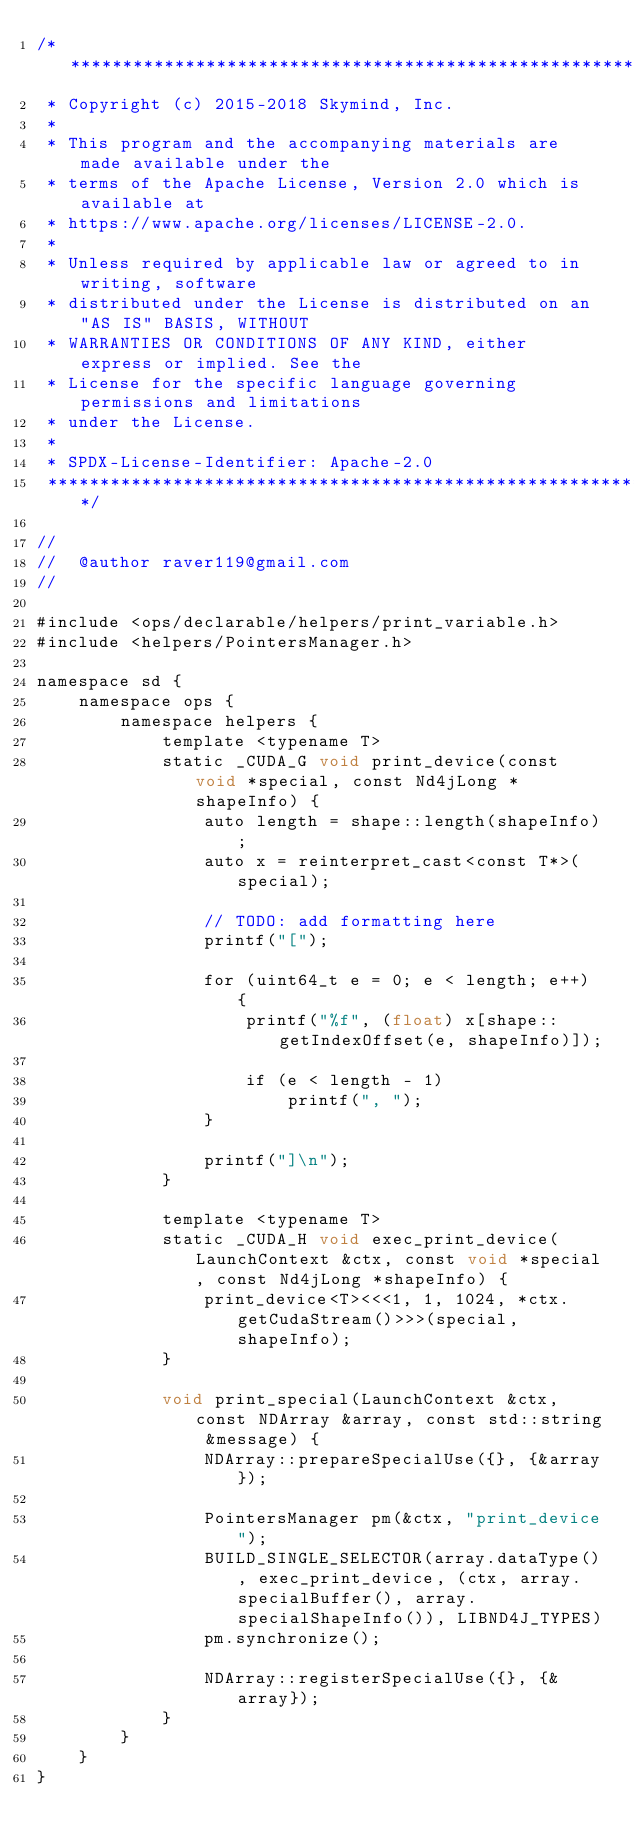<code> <loc_0><loc_0><loc_500><loc_500><_Cuda_>/*******************************************************************************
 * Copyright (c) 2015-2018 Skymind, Inc.
 *
 * This program and the accompanying materials are made available under the
 * terms of the Apache License, Version 2.0 which is available at
 * https://www.apache.org/licenses/LICENSE-2.0.
 *
 * Unless required by applicable law or agreed to in writing, software
 * distributed under the License is distributed on an "AS IS" BASIS, WITHOUT
 * WARRANTIES OR CONDITIONS OF ANY KIND, either express or implied. See the
 * License for the specific language governing permissions and limitations
 * under the License.
 *
 * SPDX-License-Identifier: Apache-2.0
 ******************************************************************************/

//
//  @author raver119@gmail.com
//

#include <ops/declarable/helpers/print_variable.h>
#include <helpers/PointersManager.h>

namespace sd {
    namespace ops {
        namespace helpers {
            template <typename T>
            static _CUDA_G void print_device(const void *special, const Nd4jLong *shapeInfo) {
                auto length = shape::length(shapeInfo);
                auto x = reinterpret_cast<const T*>(special);

                // TODO: add formatting here
                printf("[");

                for (uint64_t e = 0; e < length; e++) {
                    printf("%f", (float) x[shape::getIndexOffset(e, shapeInfo)]);

                    if (e < length - 1)
                        printf(", ");
                }

                printf("]\n");
            }

            template <typename T>
            static _CUDA_H void exec_print_device(LaunchContext &ctx, const void *special, const Nd4jLong *shapeInfo) {
                print_device<T><<<1, 1, 1024, *ctx.getCudaStream()>>>(special, shapeInfo);
            }

            void print_special(LaunchContext &ctx, const NDArray &array, const std::string &message) {
                NDArray::prepareSpecialUse({}, {&array});

                PointersManager pm(&ctx, "print_device");
                BUILD_SINGLE_SELECTOR(array.dataType(), exec_print_device, (ctx, array.specialBuffer(), array.specialShapeInfo()), LIBND4J_TYPES)
                pm.synchronize();

                NDArray::registerSpecialUse({}, {&array});
            }
        }
    }
}
</code> 